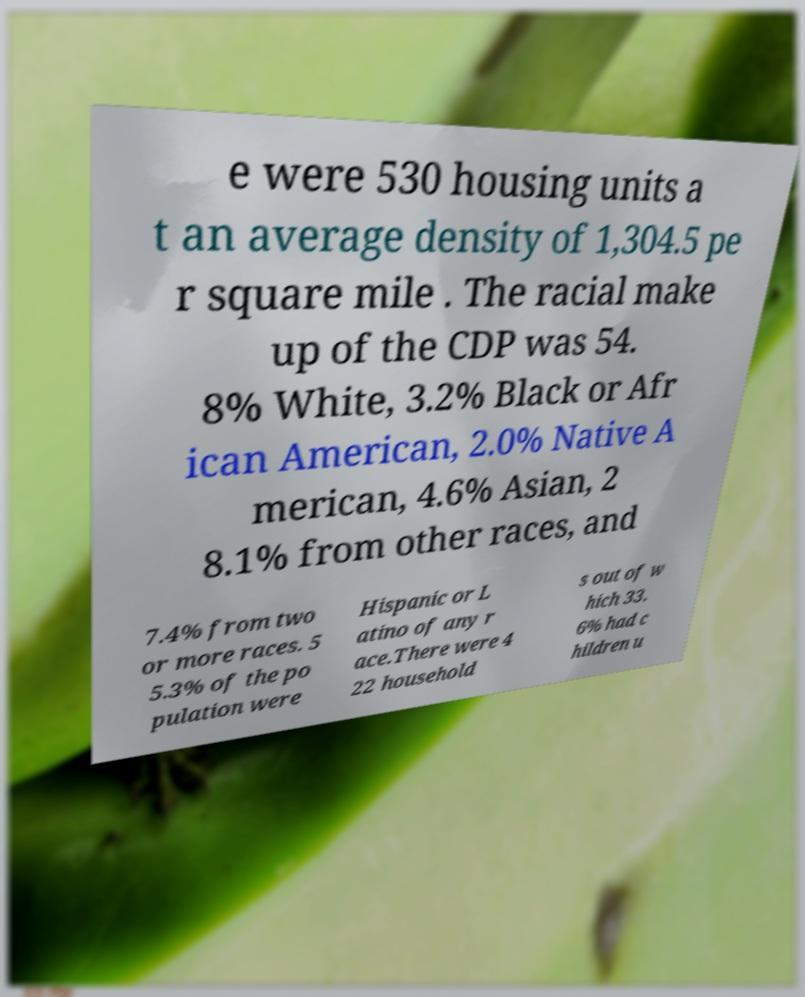Can you read and provide the text displayed in the image?This photo seems to have some interesting text. Can you extract and type it out for me? e were 530 housing units a t an average density of 1,304.5 pe r square mile . The racial make up of the CDP was 54. 8% White, 3.2% Black or Afr ican American, 2.0% Native A merican, 4.6% Asian, 2 8.1% from other races, and 7.4% from two or more races. 5 5.3% of the po pulation were Hispanic or L atino of any r ace.There were 4 22 household s out of w hich 33. 6% had c hildren u 